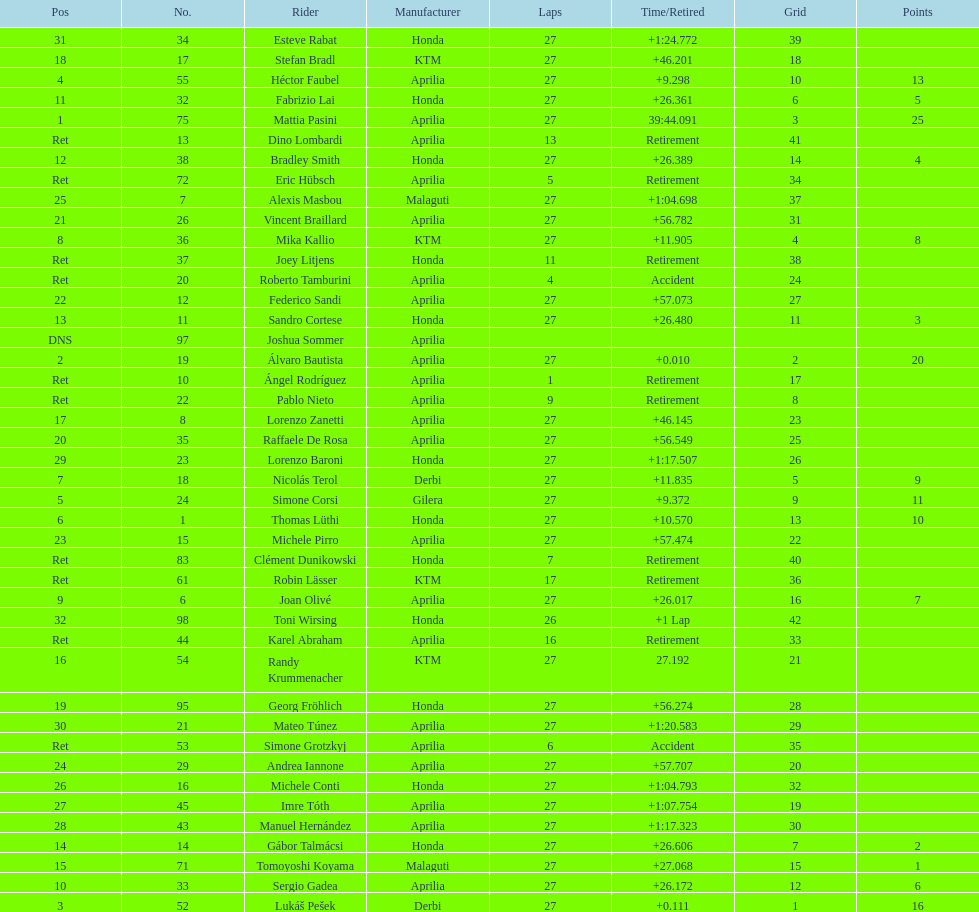Out of all the people who have points, who has the least? Tomoyoshi Koyama. 